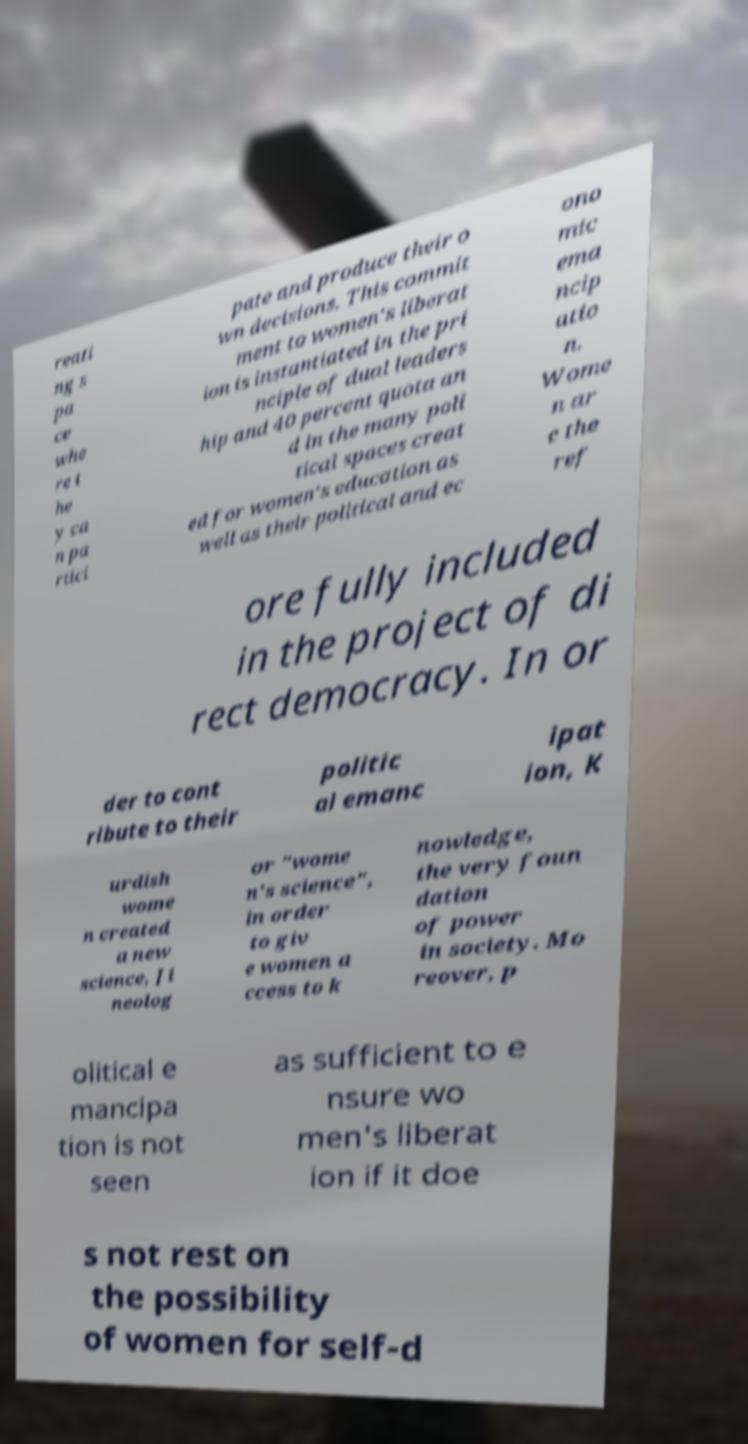Could you extract and type out the text from this image? reati ng s pa ce whe re t he y ca n pa rtici pate and produce their o wn decisions. This commit ment to women's liberat ion is instantiated in the pri nciple of dual leaders hip and 40 percent quota an d in the many poli tical spaces creat ed for women's education as well as their political and ec ono mic ema ncip atio n. Wome n ar e the ref ore fully included in the project of di rect democracy. In or der to cont ribute to their politic al emanc ipat ion, K urdish wome n created a new science, Ji neolog or "wome n's science", in order to giv e women a ccess to k nowledge, the very foun dation of power in society. Mo reover, p olitical e mancipa tion is not seen as sufficient to e nsure wo men's liberat ion if it doe s not rest on the possibility of women for self-d 